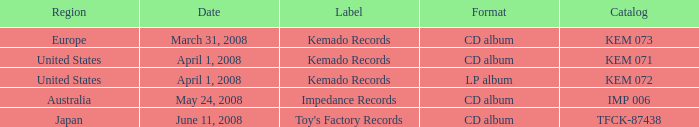Which format contains a label of toy's manufacturing logs? CD album. 